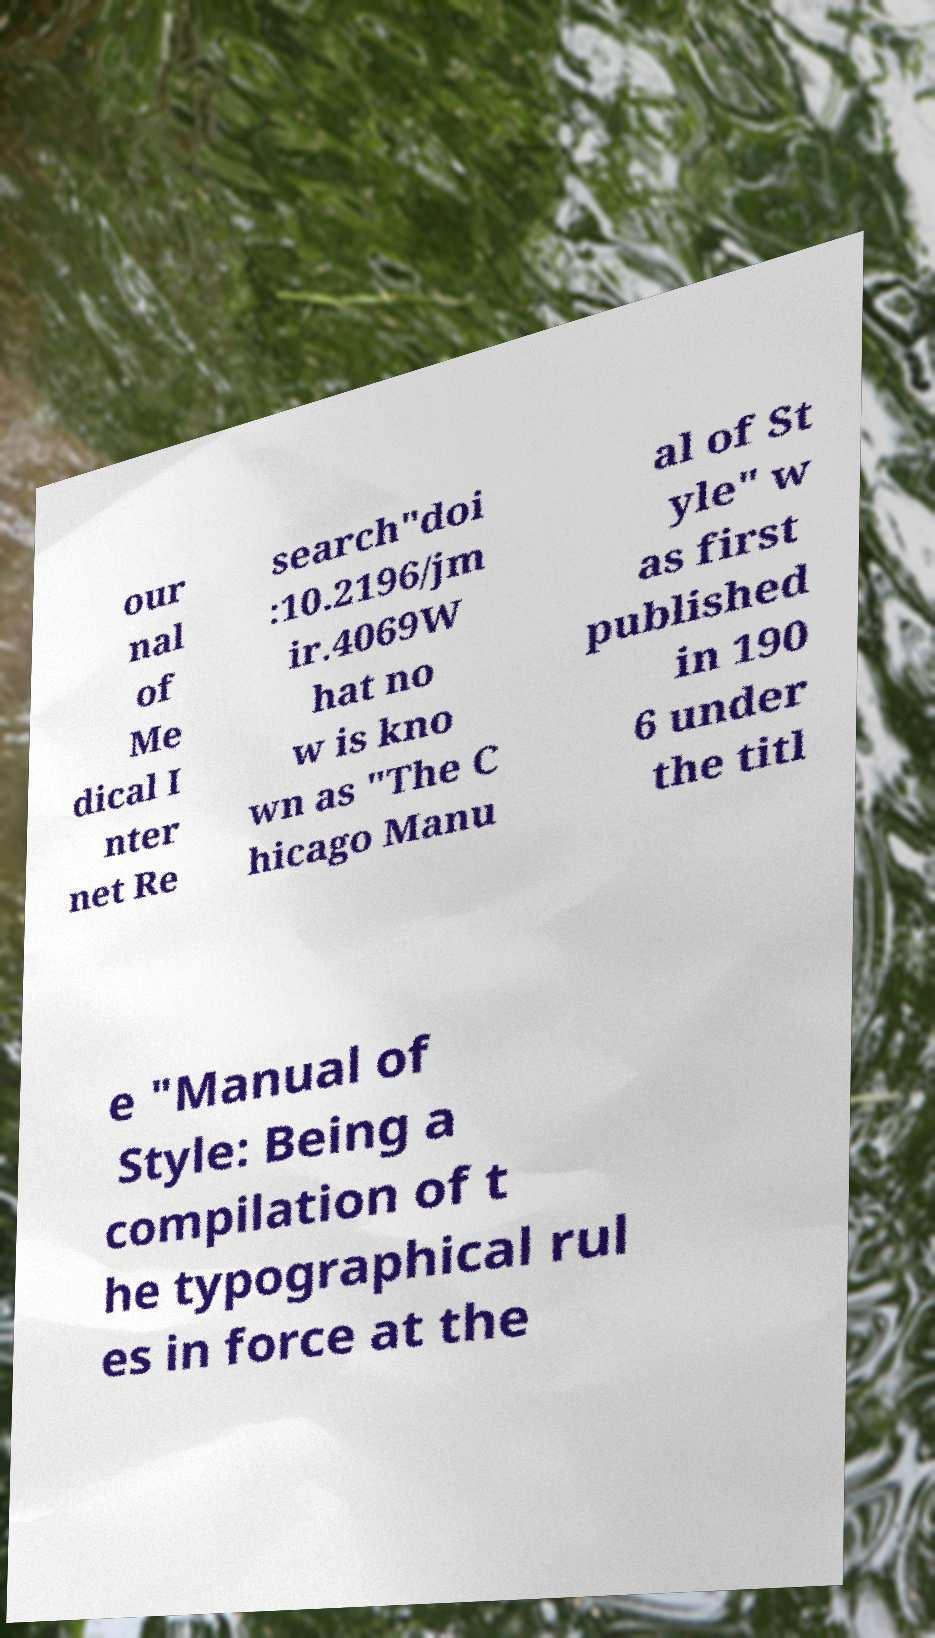Can you accurately transcribe the text from the provided image for me? our nal of Me dical I nter net Re search"doi :10.2196/jm ir.4069W hat no w is kno wn as "The C hicago Manu al of St yle" w as first published in 190 6 under the titl e "Manual of Style: Being a compilation of t he typographical rul es in force at the 